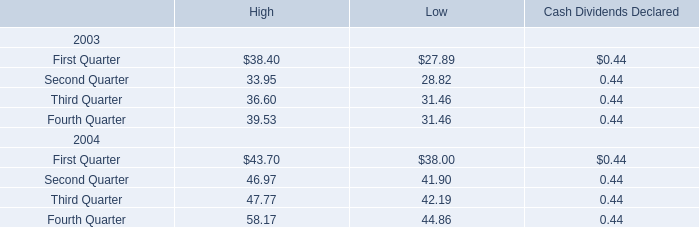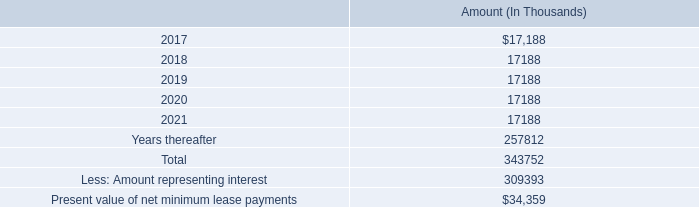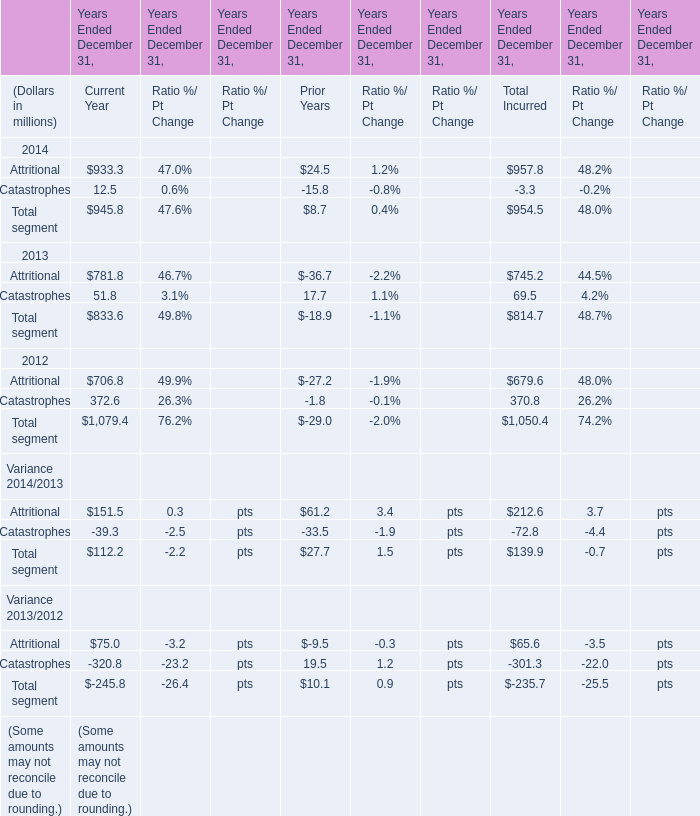what portion of the total future minimum lease payment for entergy louisiana will be used for interest payments? 
Computations: (2.3 / 57.5)
Answer: 0.04. 